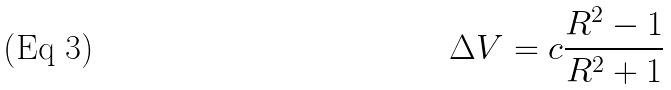Convert formula to latex. <formula><loc_0><loc_0><loc_500><loc_500>\Delta V = c \frac { R ^ { 2 } - 1 } { R ^ { 2 } + 1 }</formula> 